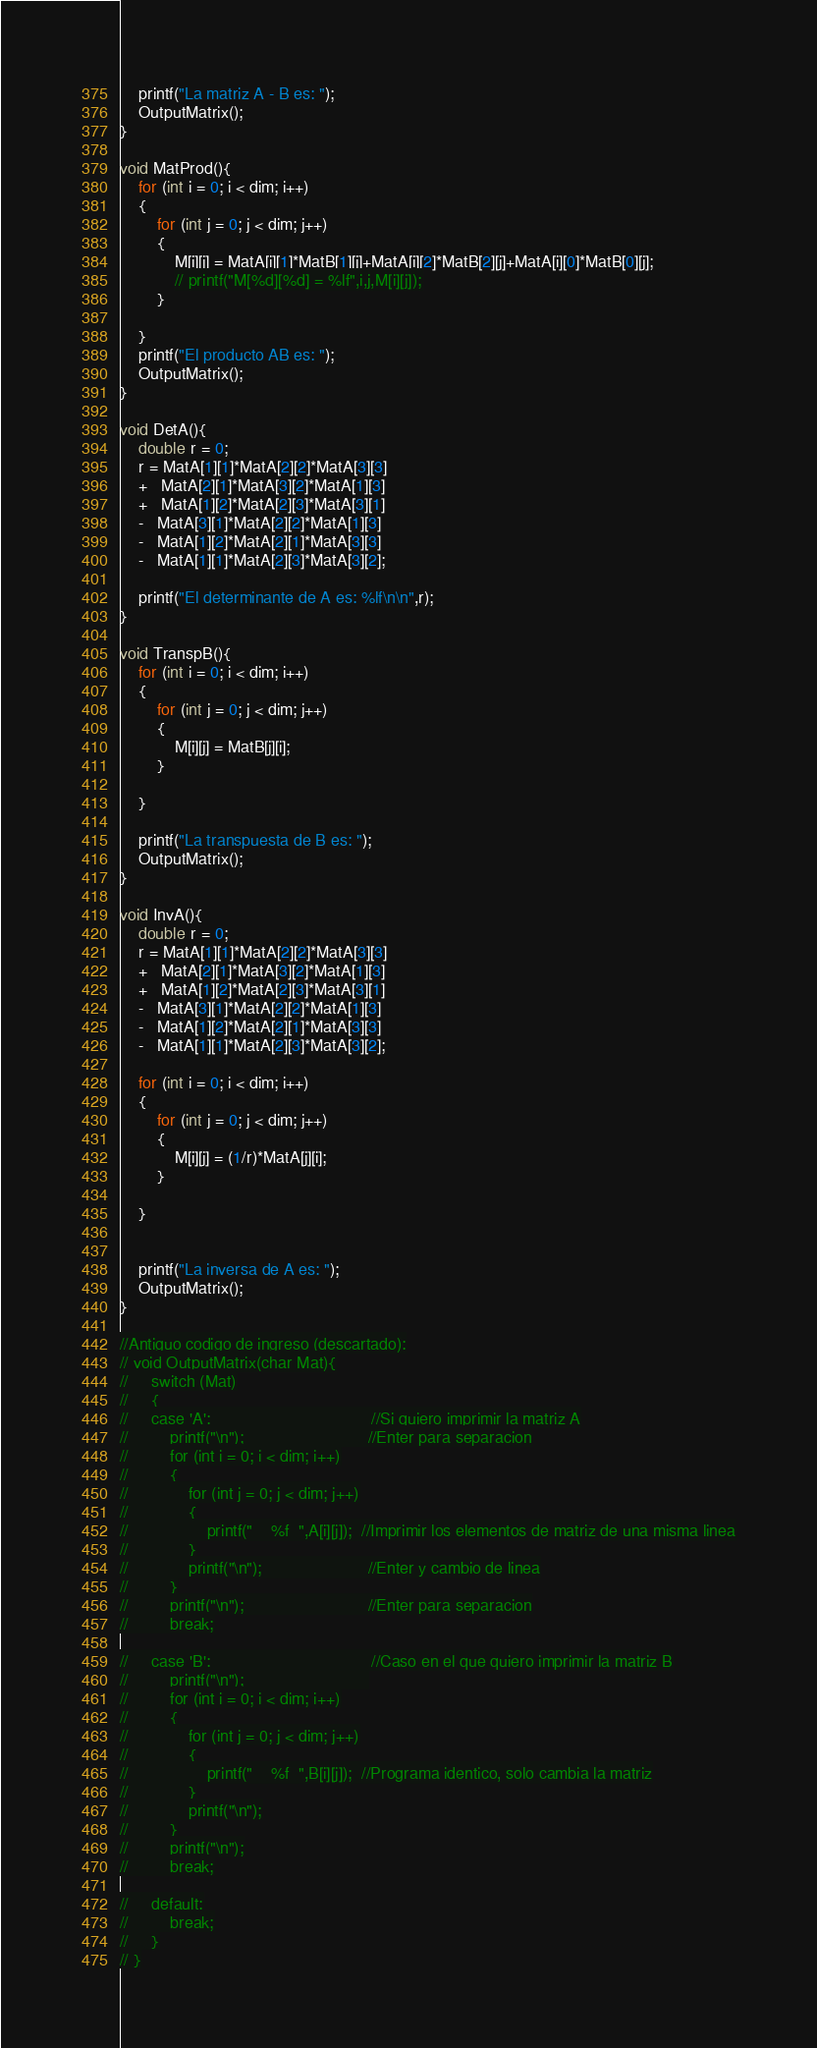<code> <loc_0><loc_0><loc_500><loc_500><_C_>    printf("La matriz A - B es: ");
    OutputMatrix();
}

void MatProd(){
    for (int i = 0; i < dim; i++)
    {
        for (int j = 0; j < dim; j++)
        {
            M[i][j] = MatA[i][1]*MatB[1][j]+MatA[i][2]*MatB[2][j]+MatA[i][0]*MatB[0][j];
            // printf("M[%d][%d] = %lf",i,j,M[i][j]);
        }
        
    }
    printf("El producto AB es: ");
    OutputMatrix();
}

void DetA(){
    double r = 0;
    r = MatA[1][1]*MatA[2][2]*MatA[3][3]
    +   MatA[2][1]*MatA[3][2]*MatA[1][3]
    +   MatA[1][2]*MatA[2][3]*MatA[3][1]
    -   MatA[3][1]*MatA[2][2]*MatA[1][3]
    -   MatA[1][2]*MatA[2][1]*MatA[3][3]
    -   MatA[1][1]*MatA[2][3]*MatA[3][2];

    printf("El determinante de A es: %lf\n\n",r);
}

void TranspB(){
    for (int i = 0; i < dim; i++)
    {
        for (int j = 0; j < dim; j++)
        {
            M[i][j] = MatB[j][i];
        }
        
    }
    
    printf("La transpuesta de B es: ");
    OutputMatrix();
}

void InvA(){
    double r = 0;
    r = MatA[1][1]*MatA[2][2]*MatA[3][3]
    +   MatA[2][1]*MatA[3][2]*MatA[1][3]
    +   MatA[1][2]*MatA[2][3]*MatA[3][1]
    -   MatA[3][1]*MatA[2][2]*MatA[1][3]
    -   MatA[1][2]*MatA[2][1]*MatA[3][3]
    -   MatA[1][1]*MatA[2][3]*MatA[3][2];

    for (int i = 0; i < dim; i++)
    {
        for (int j = 0; j < dim; j++)
        {
            M[i][j] = (1/r)*MatA[j][i];
        }
        
    }
    

    printf("La inversa de A es: ");
    OutputMatrix();
}

//Antiguo codigo de ingreso (descartado):
// void OutputMatrix(char Mat){
//     switch (Mat)
//     {
//     case 'A':                                   //Si quiero imprimir la matriz A
//         printf("\n");                           //Enter para separacion
//         for (int i = 0; i < dim; i++)
//         {
//             for (int j = 0; j < dim; j++)
//             {
//                 printf("    %f  ",A[i][j]);  //Imprimir los elementos de matriz de una misma linea
//             }
//             printf("\n");                       //Enter y cambio de linea
//         }
//         printf("\n");                           //Enter para separacion
//         break;
    
//     case 'B':                                   //Caso en el que quiero imprimir la matriz B
//         printf("\n");                           
//         for (int i = 0; i < dim; i++)
//         {
//             for (int j = 0; j < dim; j++)
//             {
//                 printf("    %f  ",B[i][j]);  //Programa identico, solo cambia la matriz
//             }
//             printf("\n");
//         }
//         printf("\n");
//         break;
    
//     default:
//         break;
//     }
// }</code> 